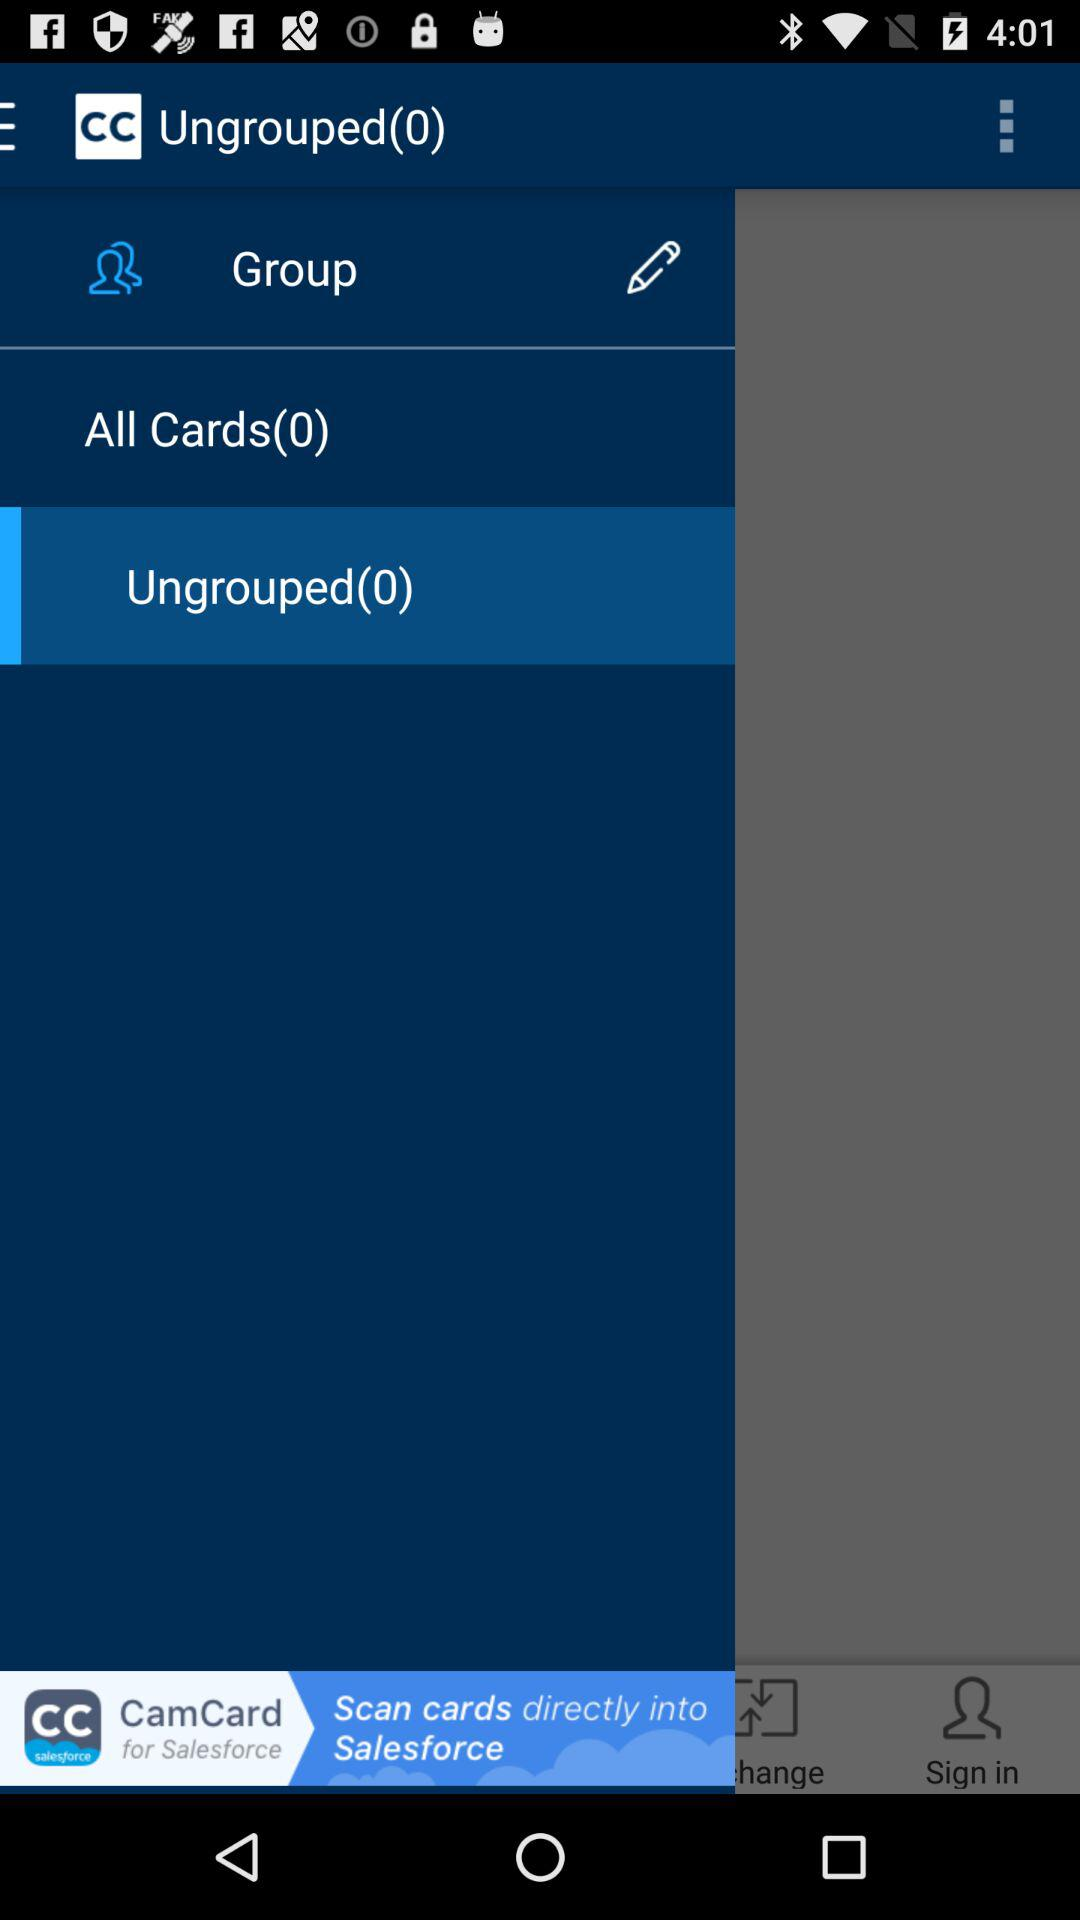How many "All Cards" are there? There are 0 "All Cards". 